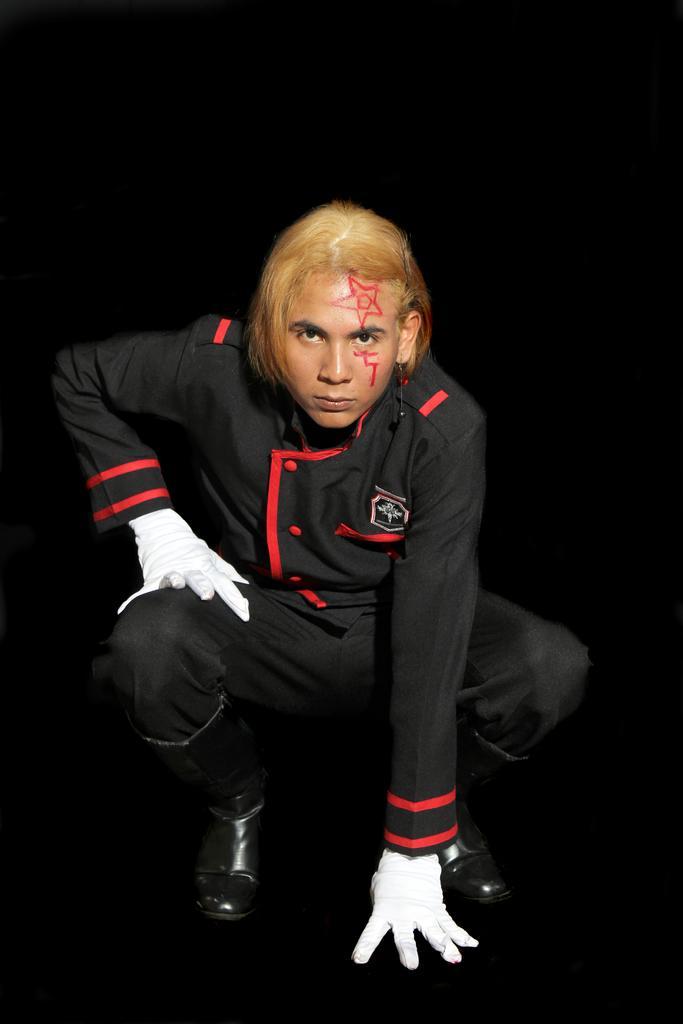Describe this image in one or two sentences. In this image I can see a person wearing black and red colored dress and white colored gloves. I can see the black colored background. 